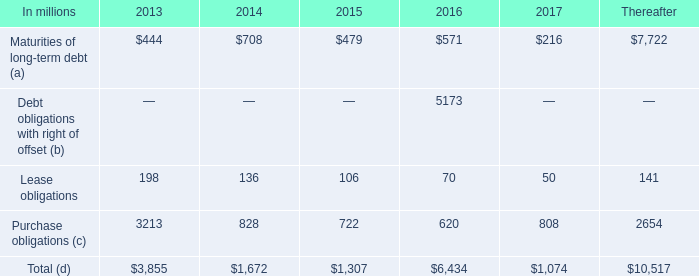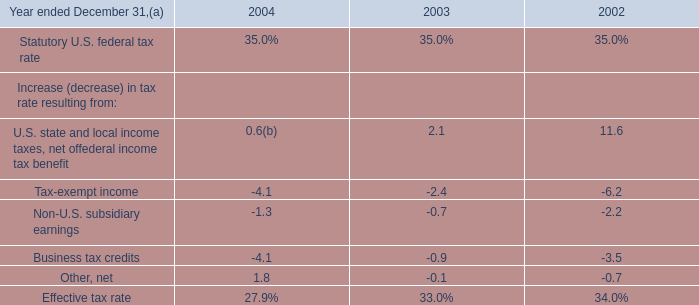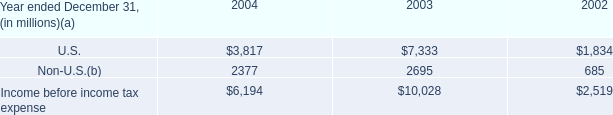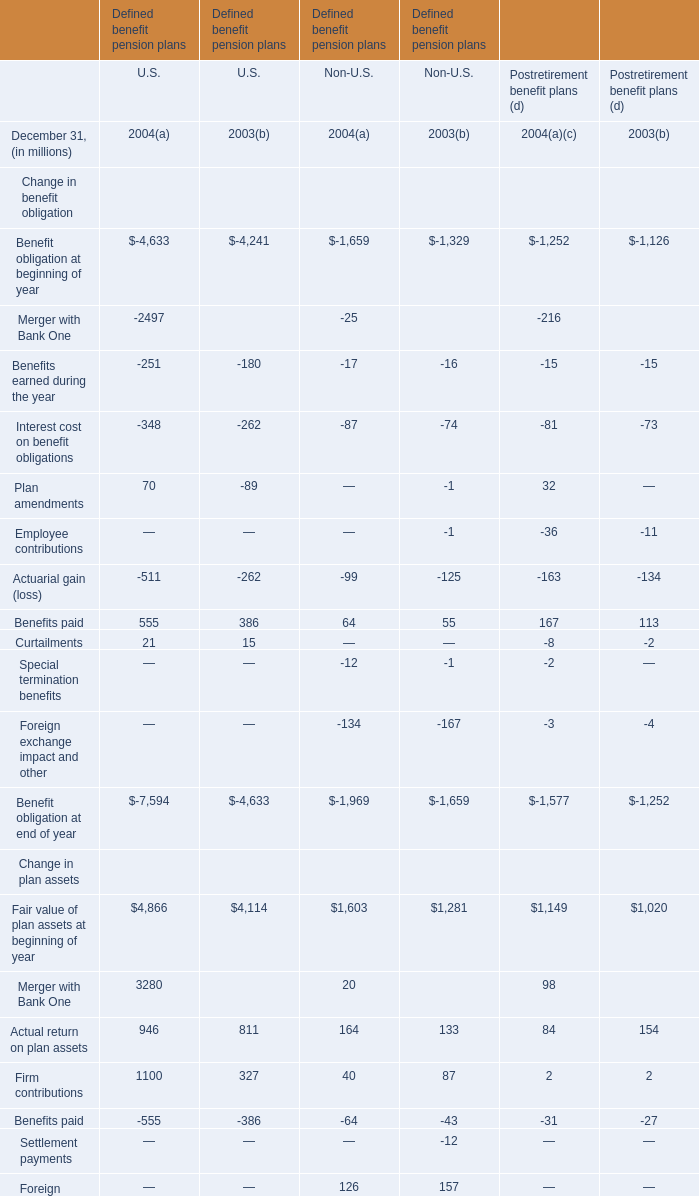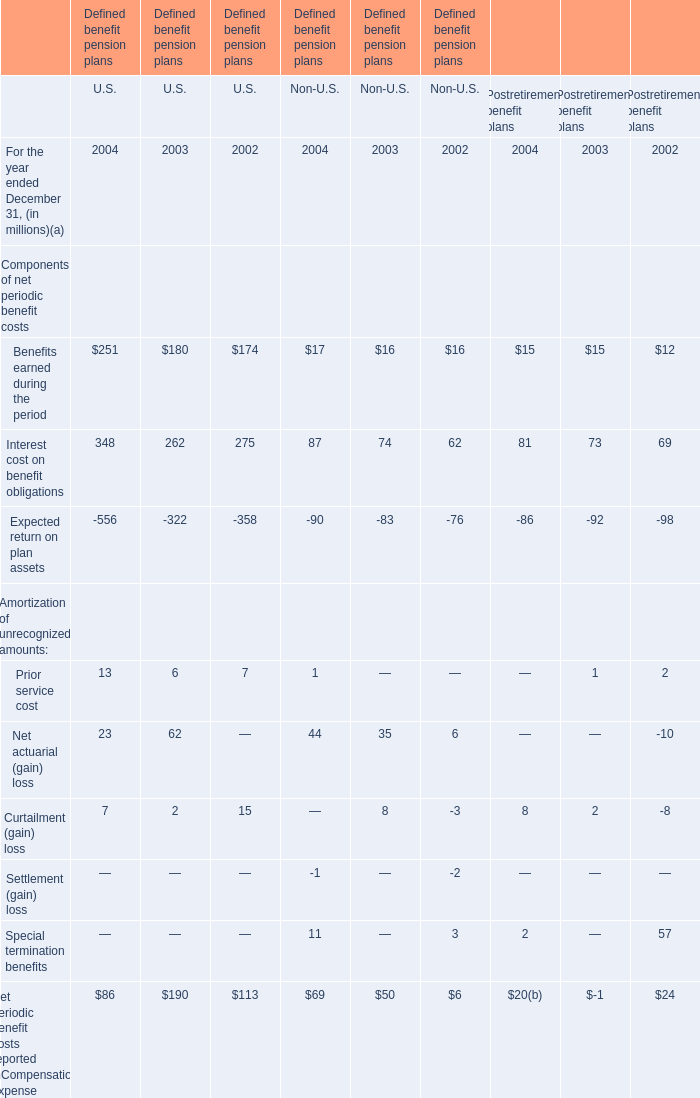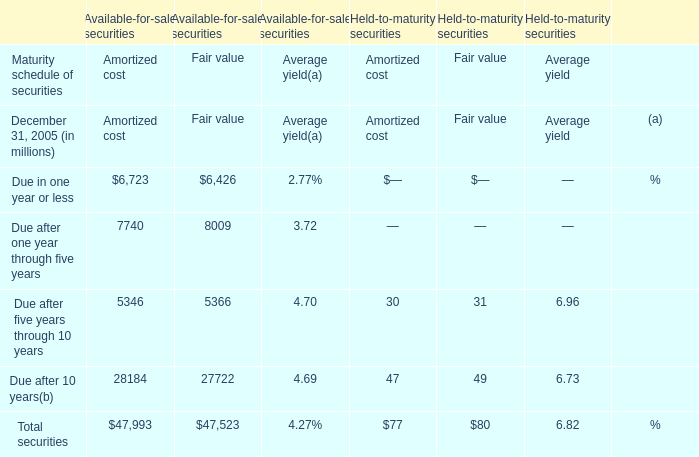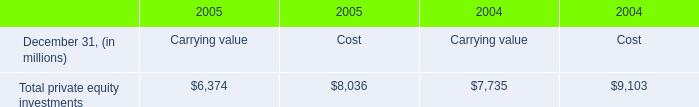If Actual return on plan assets for U.S. develops with the same growth rate in 2004, what will it reach in 2005? (in million) 
Computations: (946 * (1 + ((946 - 811) / 811)))
Answer: 1103.47226. 